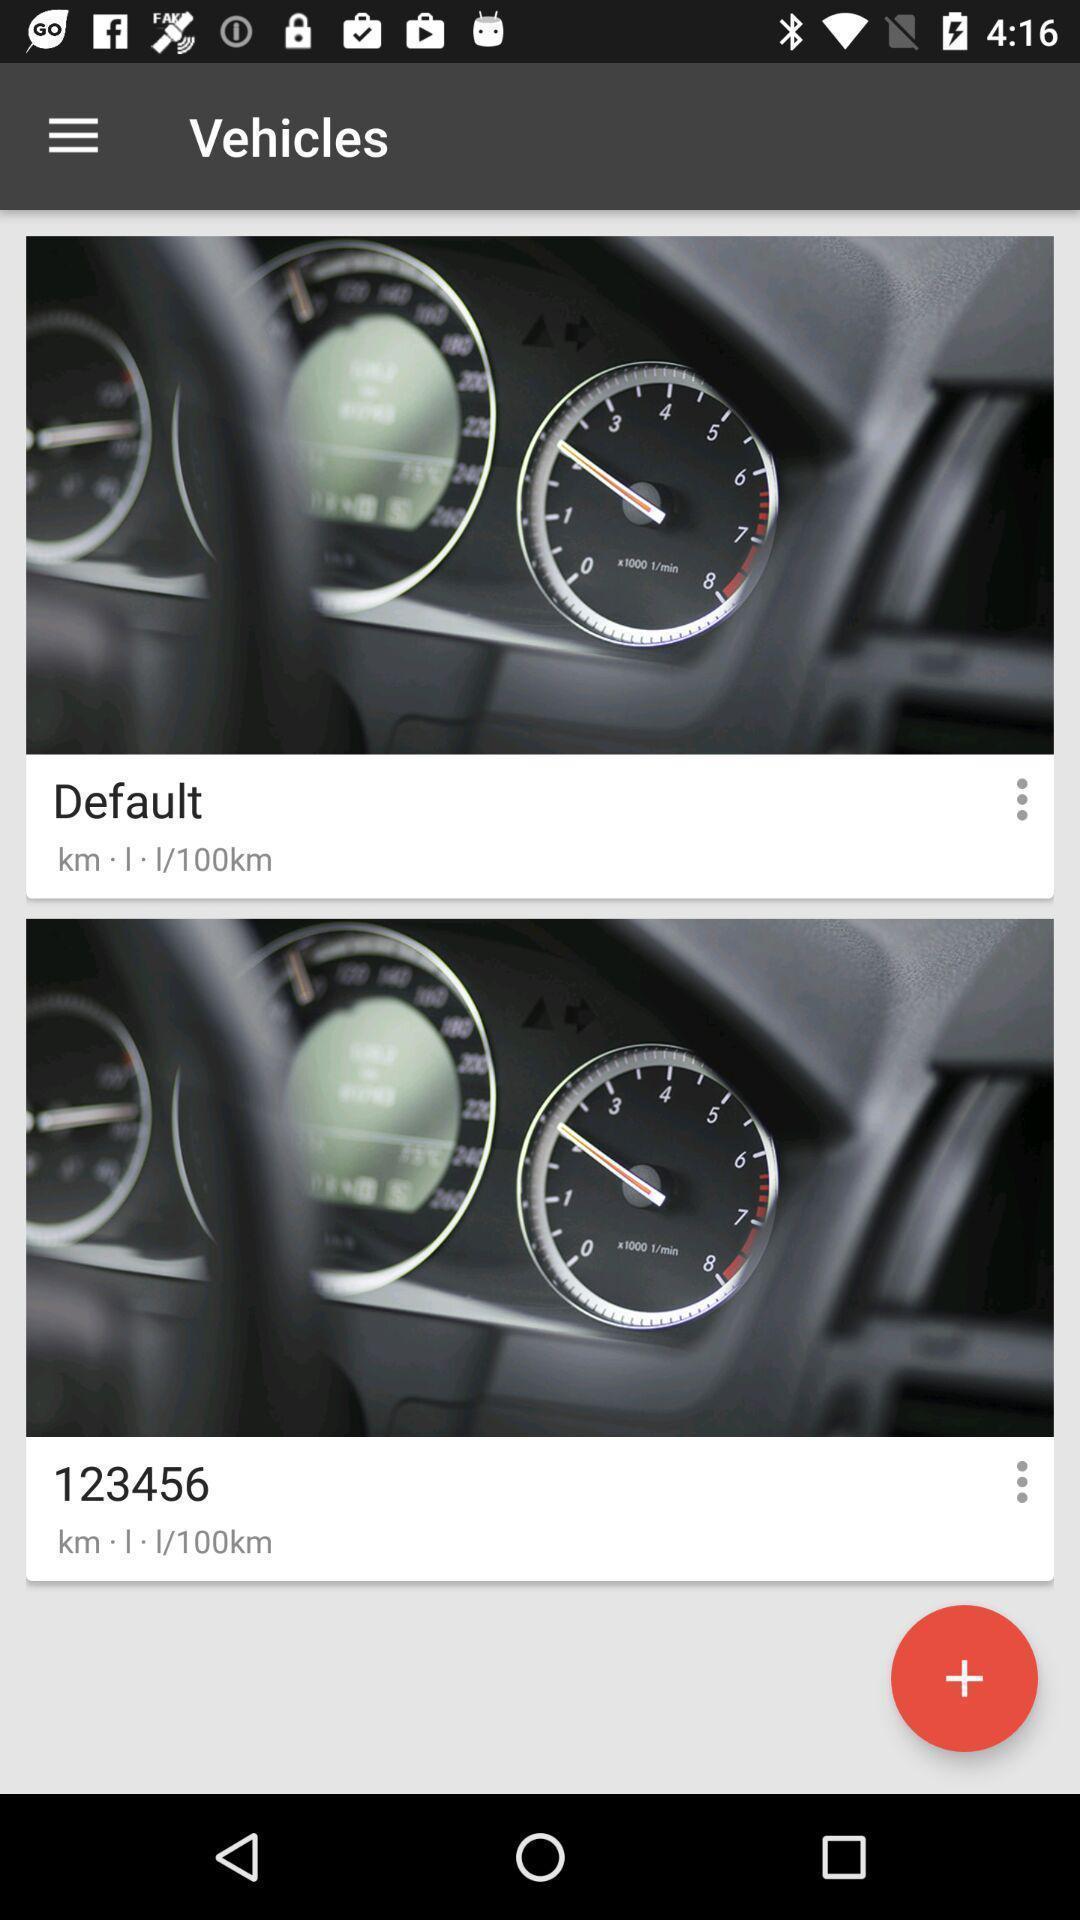Describe the visual elements of this screenshot. Vehicles page with images displayed. 